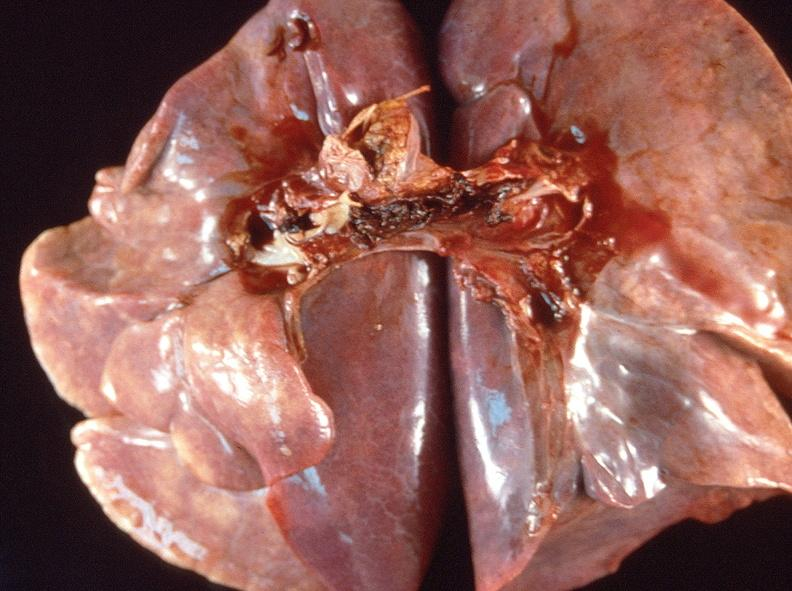does this image show pulmonary thromboemboli?
Answer the question using a single word or phrase. Yes 